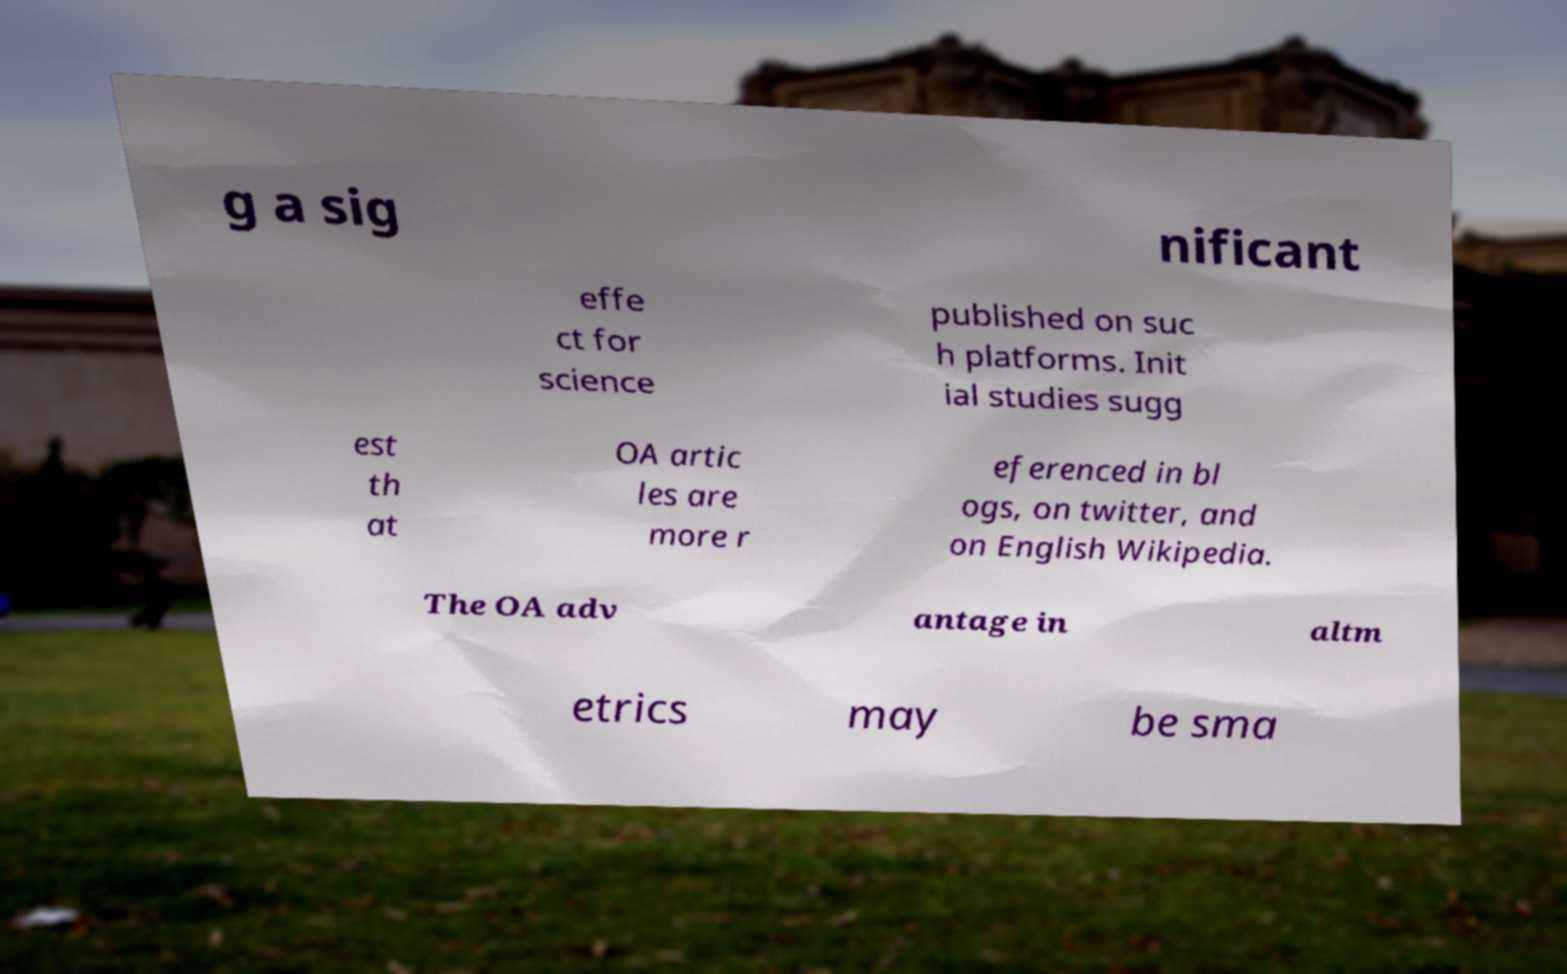I need the written content from this picture converted into text. Can you do that? g a sig nificant effe ct for science published on suc h platforms. Init ial studies sugg est th at OA artic les are more r eferenced in bl ogs, on twitter, and on English Wikipedia. The OA adv antage in altm etrics may be sma 